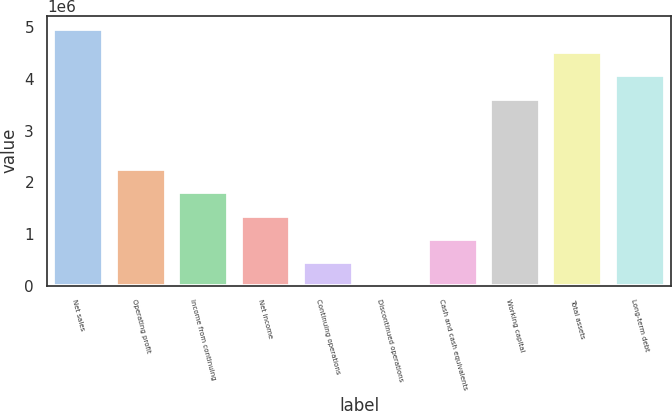Convert chart. <chart><loc_0><loc_0><loc_500><loc_500><bar_chart><fcel>Net sales<fcel>Operating profit<fcel>Income from continuing<fcel>Net income<fcel>Continuing operations<fcel>Discontinued operations<fcel>Cash and cash equivalents<fcel>Working capital<fcel>Total assets<fcel>Long-term debt<nl><fcel>4.97829e+06<fcel>2.26286e+06<fcel>1.81029e+06<fcel>1.35772e+06<fcel>452573<fcel>0.69<fcel>905145<fcel>3.62058e+06<fcel>4.52572e+06<fcel>4.07315e+06<nl></chart> 